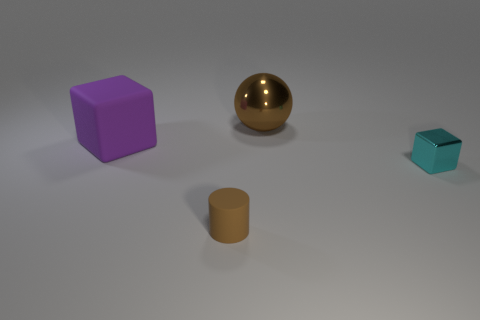Add 1 cyan cylinders. How many objects exist? 5 Subtract all balls. How many objects are left? 3 Subtract all large brown balls. Subtract all small brown rubber objects. How many objects are left? 2 Add 2 tiny rubber cylinders. How many tiny rubber cylinders are left? 3 Add 1 yellow metallic balls. How many yellow metallic balls exist? 1 Subtract 0 blue cylinders. How many objects are left? 4 